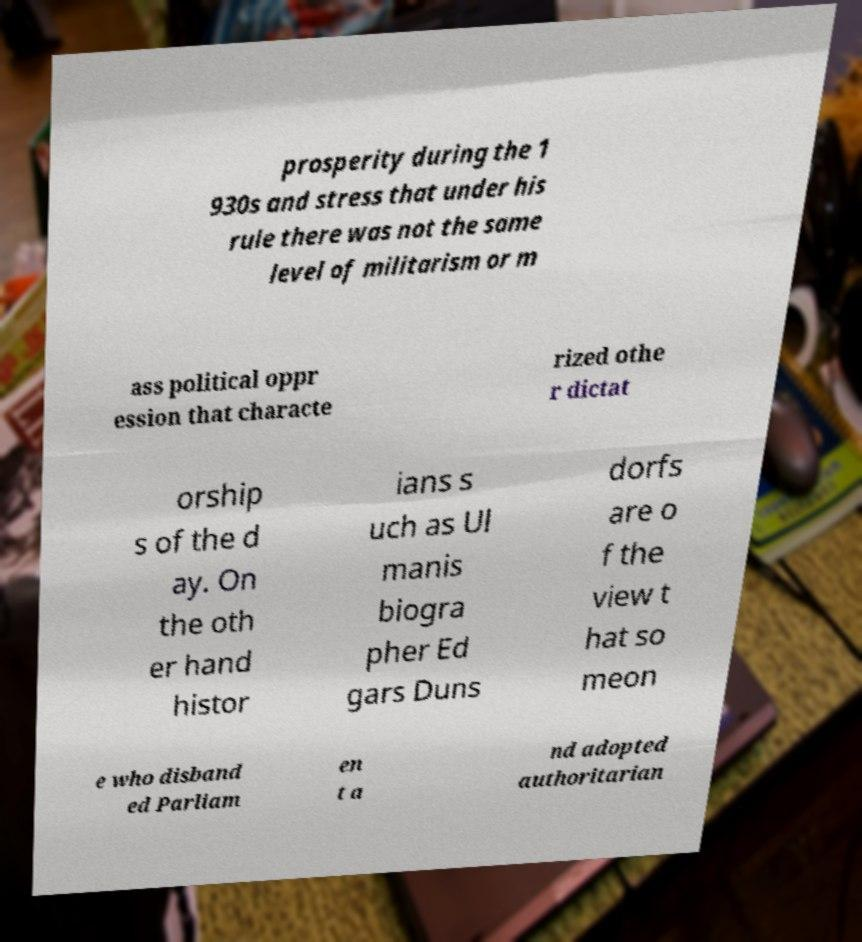What messages or text are displayed in this image? I need them in a readable, typed format. prosperity during the 1 930s and stress that under his rule there was not the same level of militarism or m ass political oppr ession that characte rized othe r dictat orship s of the d ay. On the oth er hand histor ians s uch as Ul manis biogra pher Ed gars Duns dorfs are o f the view t hat so meon e who disband ed Parliam en t a nd adopted authoritarian 